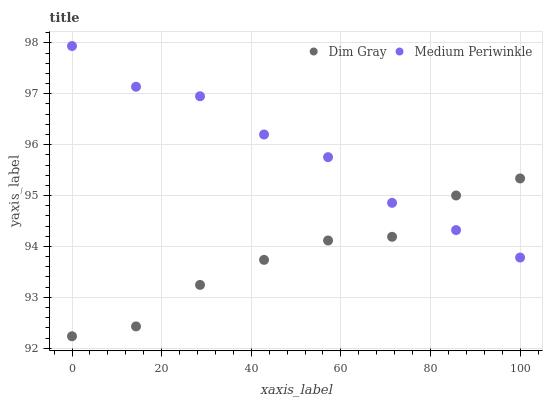Does Dim Gray have the minimum area under the curve?
Answer yes or no. Yes. Does Medium Periwinkle have the maximum area under the curve?
Answer yes or no. Yes. Does Medium Periwinkle have the minimum area under the curve?
Answer yes or no. No. Is Medium Periwinkle the smoothest?
Answer yes or no. Yes. Is Dim Gray the roughest?
Answer yes or no. Yes. Is Medium Periwinkle the roughest?
Answer yes or no. No. Does Dim Gray have the lowest value?
Answer yes or no. Yes. Does Medium Periwinkle have the lowest value?
Answer yes or no. No. Does Medium Periwinkle have the highest value?
Answer yes or no. Yes. Does Medium Periwinkle intersect Dim Gray?
Answer yes or no. Yes. Is Medium Periwinkle less than Dim Gray?
Answer yes or no. No. Is Medium Periwinkle greater than Dim Gray?
Answer yes or no. No. 